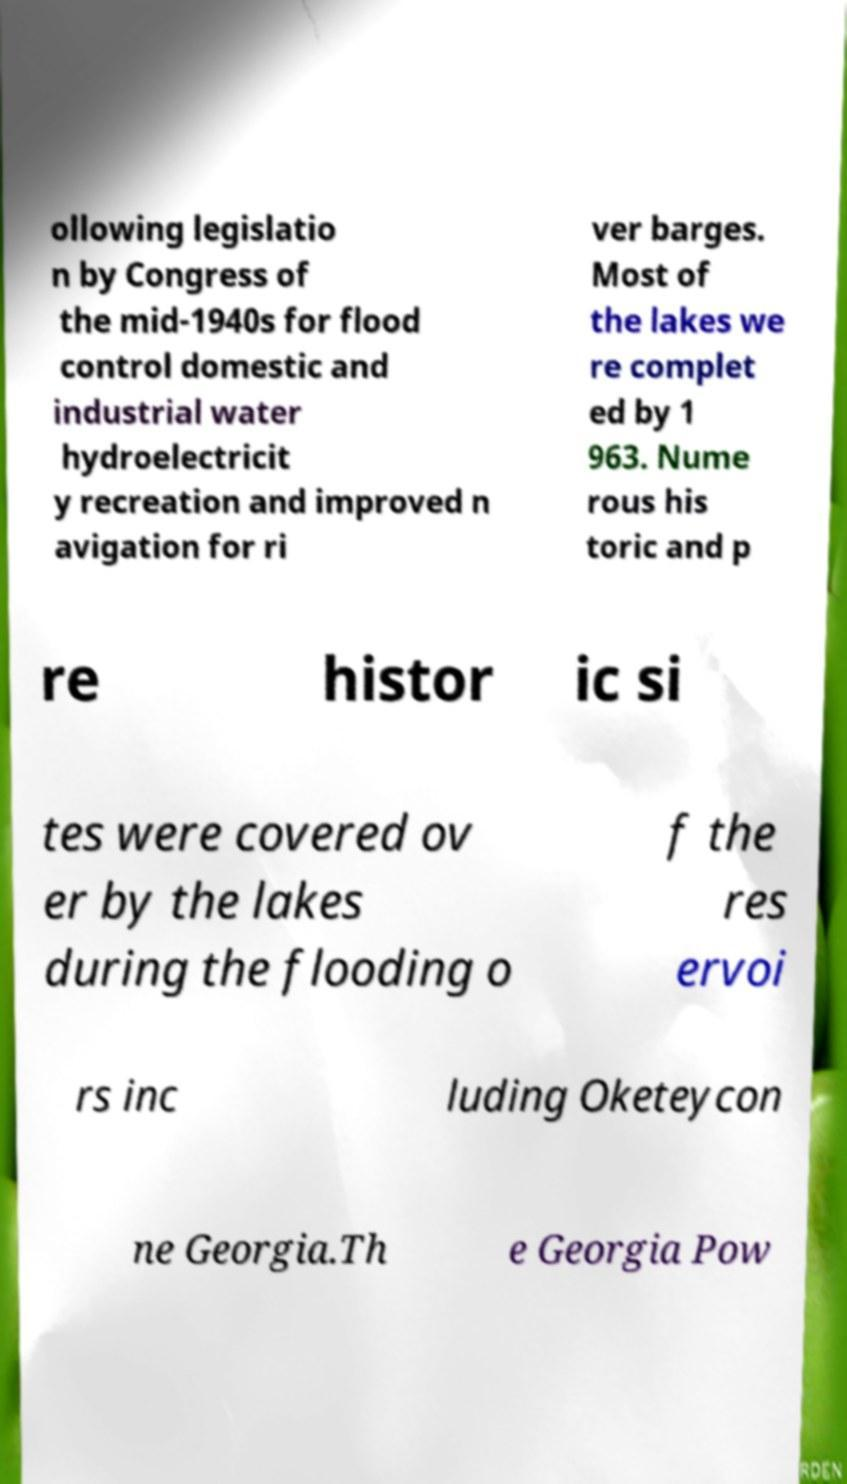I need the written content from this picture converted into text. Can you do that? ollowing legislatio n by Congress of the mid-1940s for flood control domestic and industrial water hydroelectricit y recreation and improved n avigation for ri ver barges. Most of the lakes we re complet ed by 1 963. Nume rous his toric and p re histor ic si tes were covered ov er by the lakes during the flooding o f the res ervoi rs inc luding Oketeycon ne Georgia.Th e Georgia Pow 